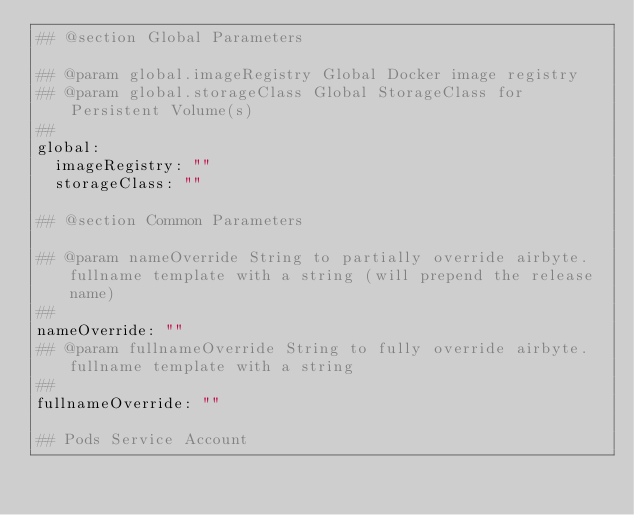Convert code to text. <code><loc_0><loc_0><loc_500><loc_500><_YAML_>## @section Global Parameters

## @param global.imageRegistry Global Docker image registry
## @param global.storageClass Global StorageClass for Persistent Volume(s)
##
global:
  imageRegistry: ""
  storageClass: ""

## @section Common Parameters

## @param nameOverride String to partially override airbyte.fullname template with a string (will prepend the release name)
##
nameOverride: ""
## @param fullnameOverride String to fully override airbyte.fullname template with a string
##
fullnameOverride: ""

## Pods Service Account</code> 